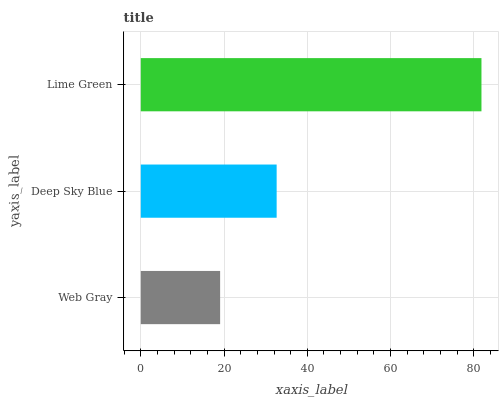Is Web Gray the minimum?
Answer yes or no. Yes. Is Lime Green the maximum?
Answer yes or no. Yes. Is Deep Sky Blue the minimum?
Answer yes or no. No. Is Deep Sky Blue the maximum?
Answer yes or no. No. Is Deep Sky Blue greater than Web Gray?
Answer yes or no. Yes. Is Web Gray less than Deep Sky Blue?
Answer yes or no. Yes. Is Web Gray greater than Deep Sky Blue?
Answer yes or no. No. Is Deep Sky Blue less than Web Gray?
Answer yes or no. No. Is Deep Sky Blue the high median?
Answer yes or no. Yes. Is Deep Sky Blue the low median?
Answer yes or no. Yes. Is Web Gray the high median?
Answer yes or no. No. Is Lime Green the low median?
Answer yes or no. No. 